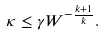Convert formula to latex. <formula><loc_0><loc_0><loc_500><loc_500>\kappa \leq \gamma W ^ { - \frac { k + 1 } { k } } .</formula> 